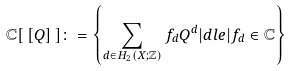<formula> <loc_0><loc_0><loc_500><loc_500>\mathbb { C } [ \, [ Q ] \, ] \colon = \left \{ \sum _ { d \in H _ { 2 } ( X ; \mathbb { Z } ) } f _ { d } Q ^ { d } | d l e | f _ { d } \in \mathbb { C } \right \}</formula> 